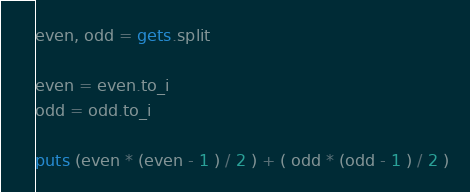<code> <loc_0><loc_0><loc_500><loc_500><_Ruby_>even, odd = gets.split

even = even.to_i
odd = odd.to_i

puts (even * (even - 1 ) / 2 ) + ( odd * (odd - 1 ) / 2 )</code> 